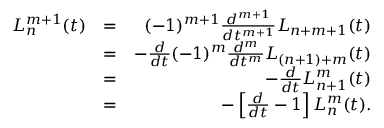<formula> <loc_0><loc_0><loc_500><loc_500>\begin{array} { r l r } { L _ { n } ^ { m + 1 } ( t ) } & { = } & { ( - 1 ) ^ { m + 1 } \frac { d ^ { m + 1 } } { d t ^ { m + 1 } } L _ { n + m + 1 } ( t ) } \\ & { = } & { - \frac { d } { d t } ( - 1 ) ^ { m } \frac { d ^ { m } } { d t ^ { m } } L _ { ( n + 1 ) + m } ( t ) } \\ & { = } & { - \frac { d } { d t } L _ { n + 1 } ^ { m } ( t ) } \\ & { = } & { - \left [ \frac { d } { d t } - 1 \right ] L _ { n } ^ { m } ( t ) . } \end{array}</formula> 